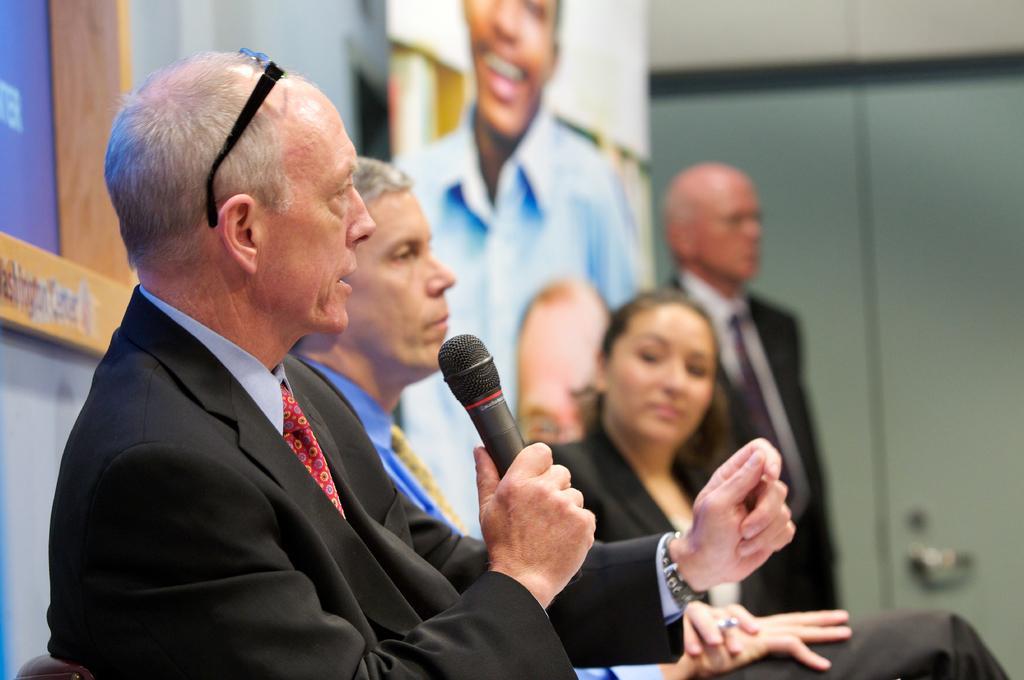How would you summarize this image in a sentence or two? This image consists of four people. They have banners behind them. The one who is in the front side is holding a mic and he also has specs. Three of them are sitting and the one who is on the right side is standing. All of them wore black dresses. 